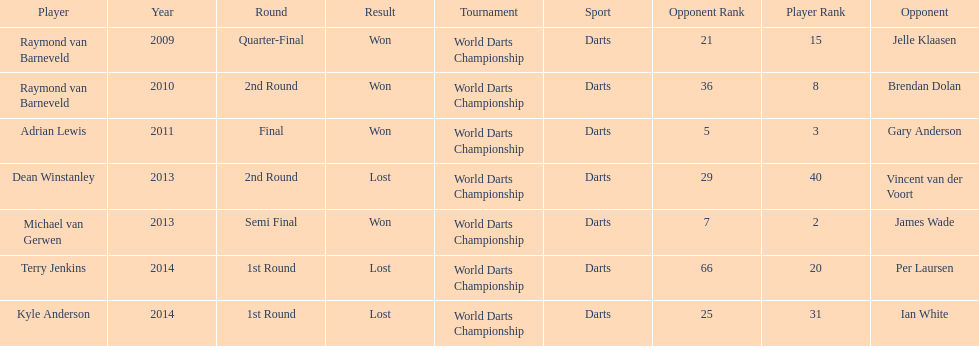Who claimed victory in 2014, terry jenkins or per laursen? Per Laursen. 